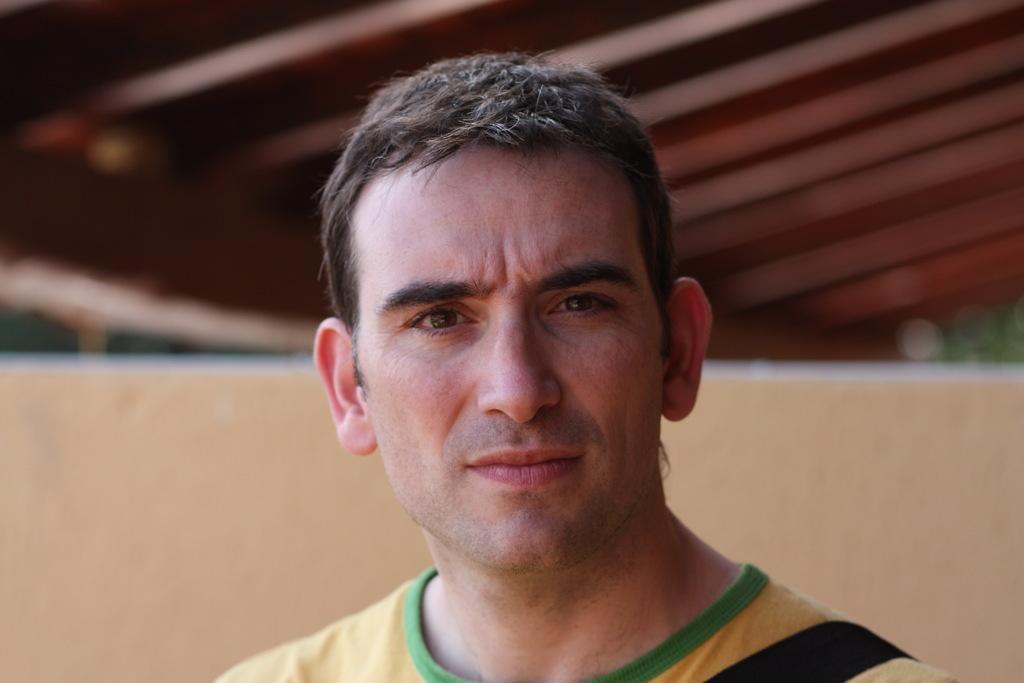Can you describe this image briefly? In this image, I can see the man. He wore a T-shirt. In the background, I think this is the wall. At the top of the image, that looks like a roof. 